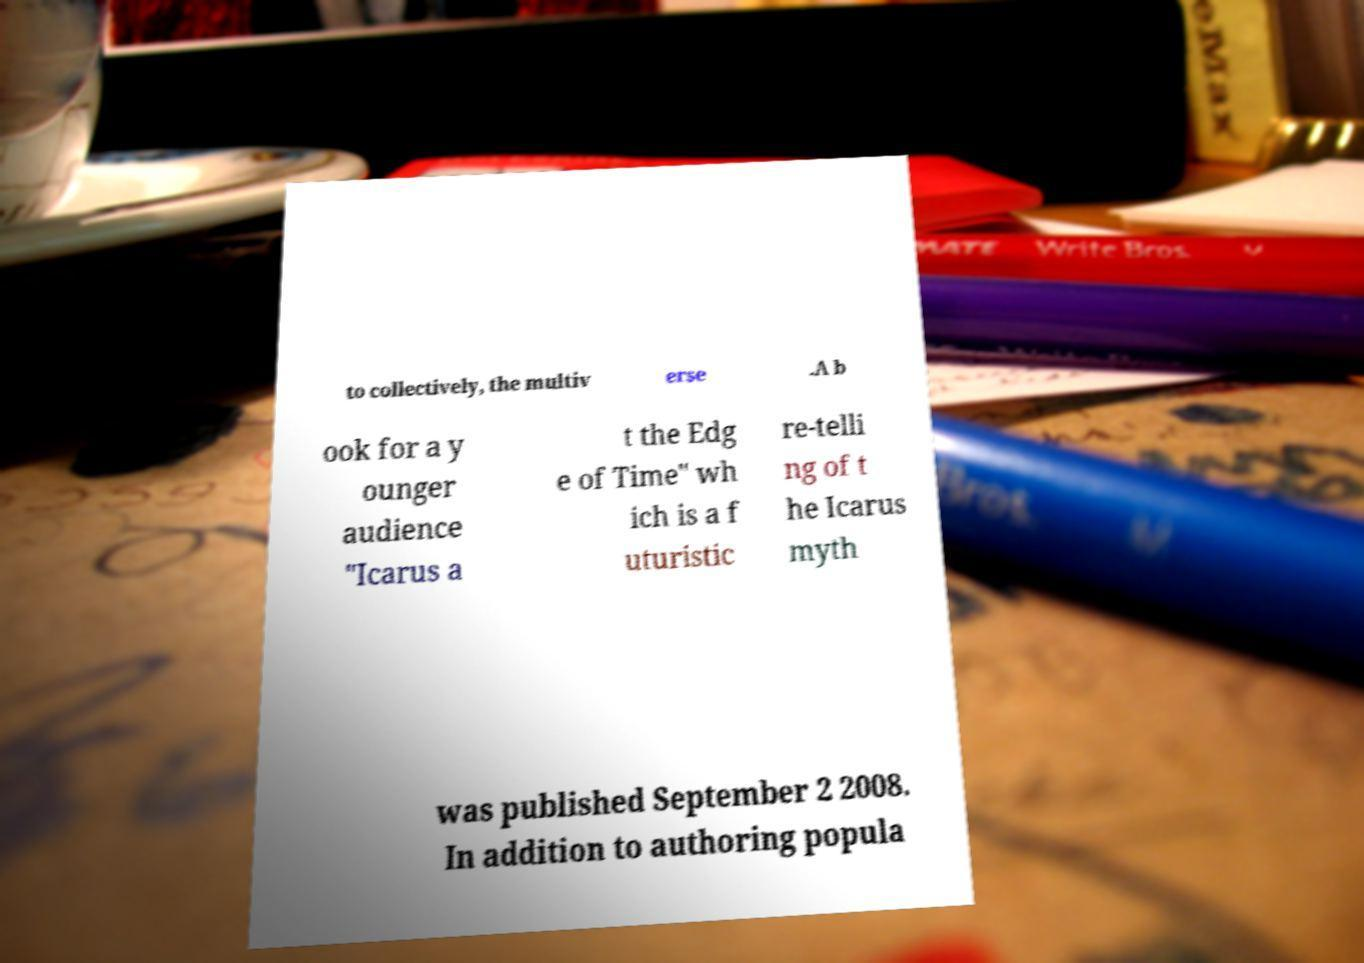Could you assist in decoding the text presented in this image and type it out clearly? to collectively, the multiv erse .A b ook for a y ounger audience "Icarus a t the Edg e of Time" wh ich is a f uturistic re-telli ng of t he Icarus myth was published September 2 2008. In addition to authoring popula 